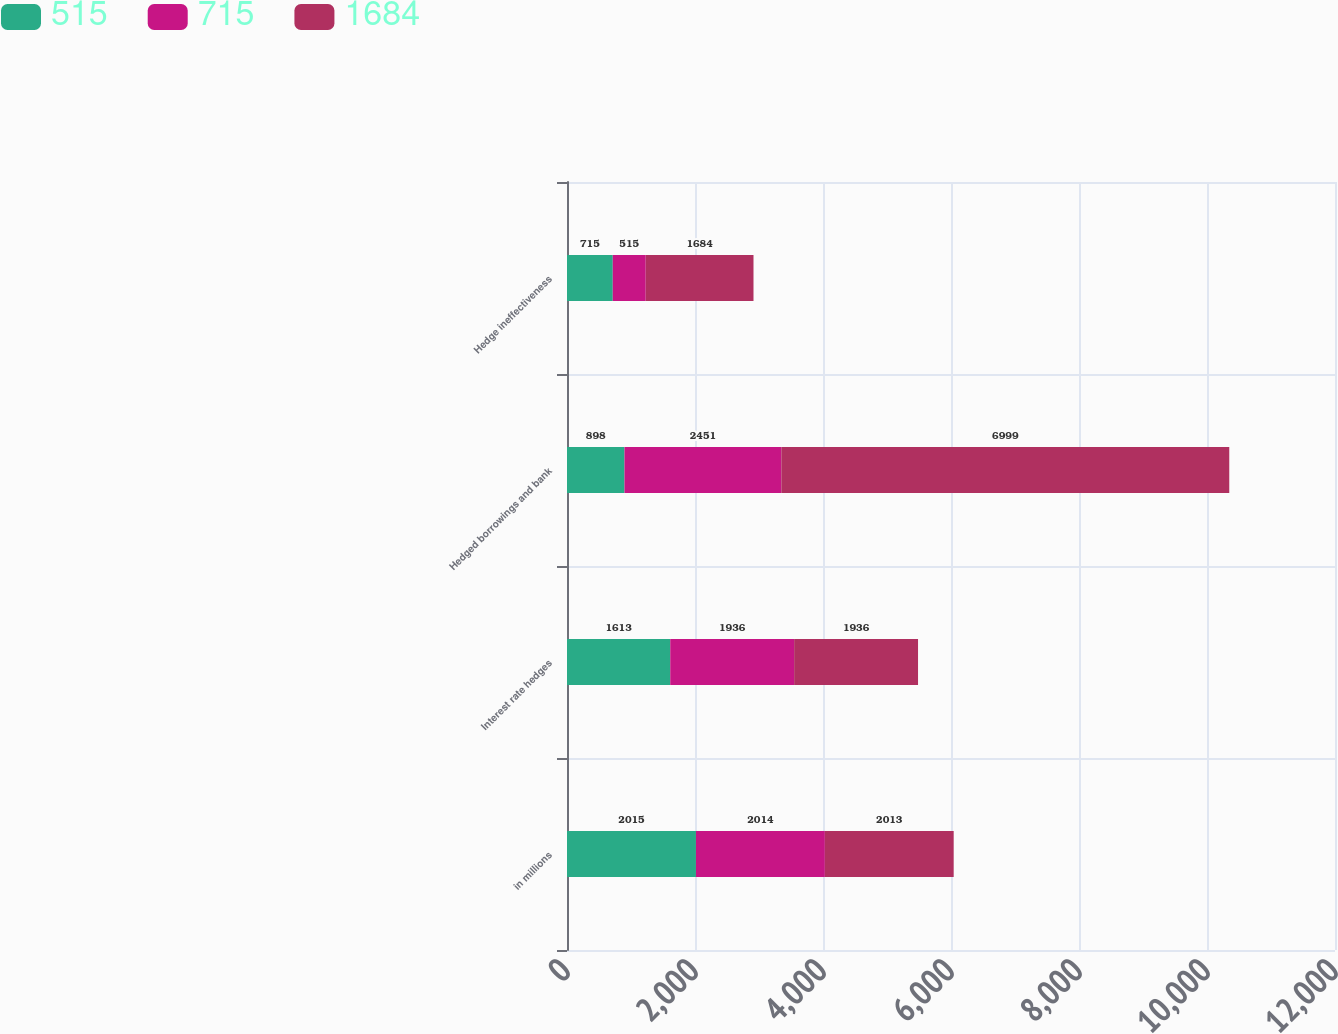Convert chart. <chart><loc_0><loc_0><loc_500><loc_500><stacked_bar_chart><ecel><fcel>in millions<fcel>Interest rate hedges<fcel>Hedged borrowings and bank<fcel>Hedge ineffectiveness<nl><fcel>515<fcel>2015<fcel>1613<fcel>898<fcel>715<nl><fcel>715<fcel>2014<fcel>1936<fcel>2451<fcel>515<nl><fcel>1684<fcel>2013<fcel>1936<fcel>6999<fcel>1684<nl></chart> 